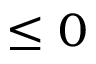Convert formula to latex. <formula><loc_0><loc_0><loc_500><loc_500>\leq 0</formula> 